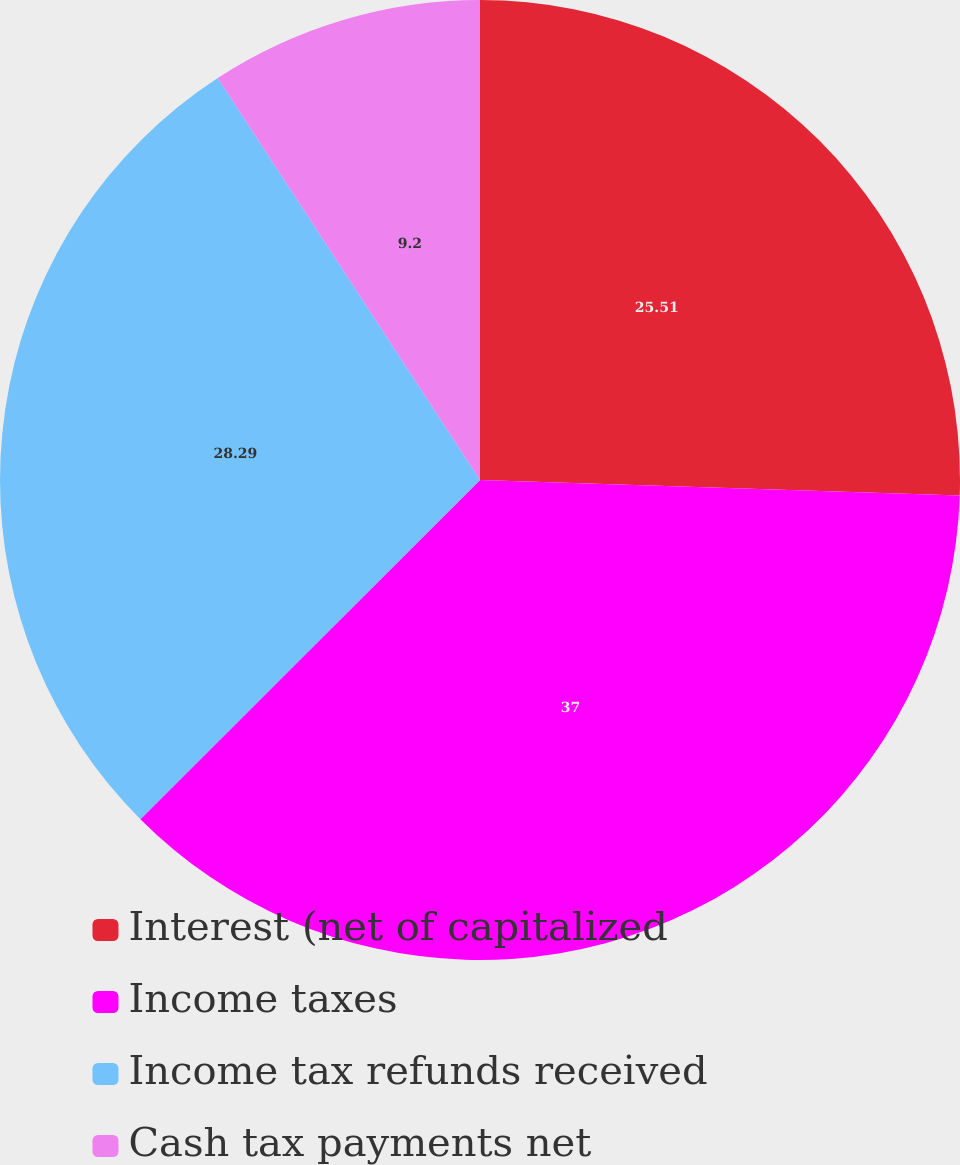Convert chart to OTSL. <chart><loc_0><loc_0><loc_500><loc_500><pie_chart><fcel>Interest (net of capitalized<fcel>Income taxes<fcel>Income tax refunds received<fcel>Cash tax payments net<nl><fcel>25.51%<fcel>37.0%<fcel>28.29%<fcel>9.2%<nl></chart> 